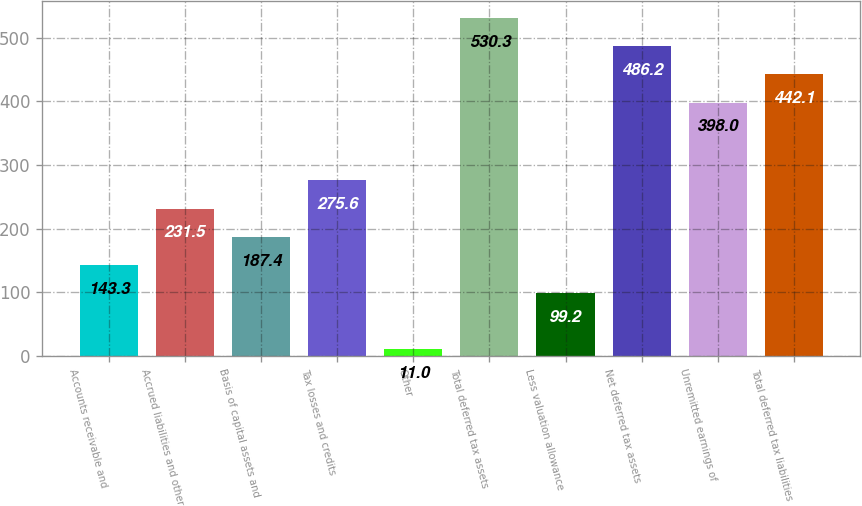<chart> <loc_0><loc_0><loc_500><loc_500><bar_chart><fcel>Accounts receivable and<fcel>Accrued liabilities and other<fcel>Basis of capital assets and<fcel>Tax losses and credits<fcel>Other<fcel>Total deferred tax assets<fcel>Less valuation allowance<fcel>Net deferred tax assets<fcel>Unremitted earnings of<fcel>Total deferred tax liabilities<nl><fcel>143.3<fcel>231.5<fcel>187.4<fcel>275.6<fcel>11<fcel>530.3<fcel>99.2<fcel>486.2<fcel>398<fcel>442.1<nl></chart> 